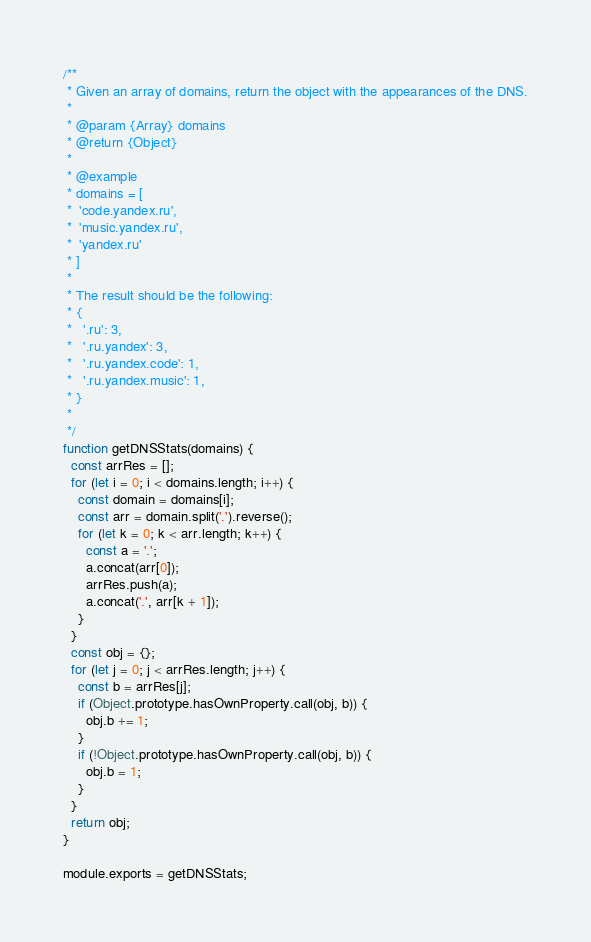Convert code to text. <code><loc_0><loc_0><loc_500><loc_500><_JavaScript_>/**
 * Given an array of domains, return the object with the appearances of the DNS.
 *
 * @param {Array} domains
 * @return {Object}
 *
 * @example
 * domains = [
 *  'code.yandex.ru',
 *  'music.yandex.ru',
 *  'yandex.ru'
 * ]
 *
 * The result should be the following:
 * {
 *   '.ru': 3,
 *   '.ru.yandex': 3,
 *   '.ru.yandex.code': 1,
 *   '.ru.yandex.music': 1,
 * }
 *
 */
function getDNSStats(domains) {
  const arrRes = [];
  for (let i = 0; i < domains.length; i++) {
    const domain = domains[i];
    const arr = domain.split('.').reverse();
    for (let k = 0; k < arr.length; k++) {
      const a = '.';
      a.concat(arr[0]);
      arrRes.push(a);
      a.concat('.', arr[k + 1]);
    }
  }
  const obj = {};
  for (let j = 0; j < arrRes.length; j++) {
    const b = arrRes[j];
    if (Object.prototype.hasOwnProperty.call(obj, b)) {
      obj.b += 1;
    }
    if (!Object.prototype.hasOwnProperty.call(obj, b)) {
      obj.b = 1;
    }
  }
  return obj;
}

module.exports = getDNSStats;
</code> 